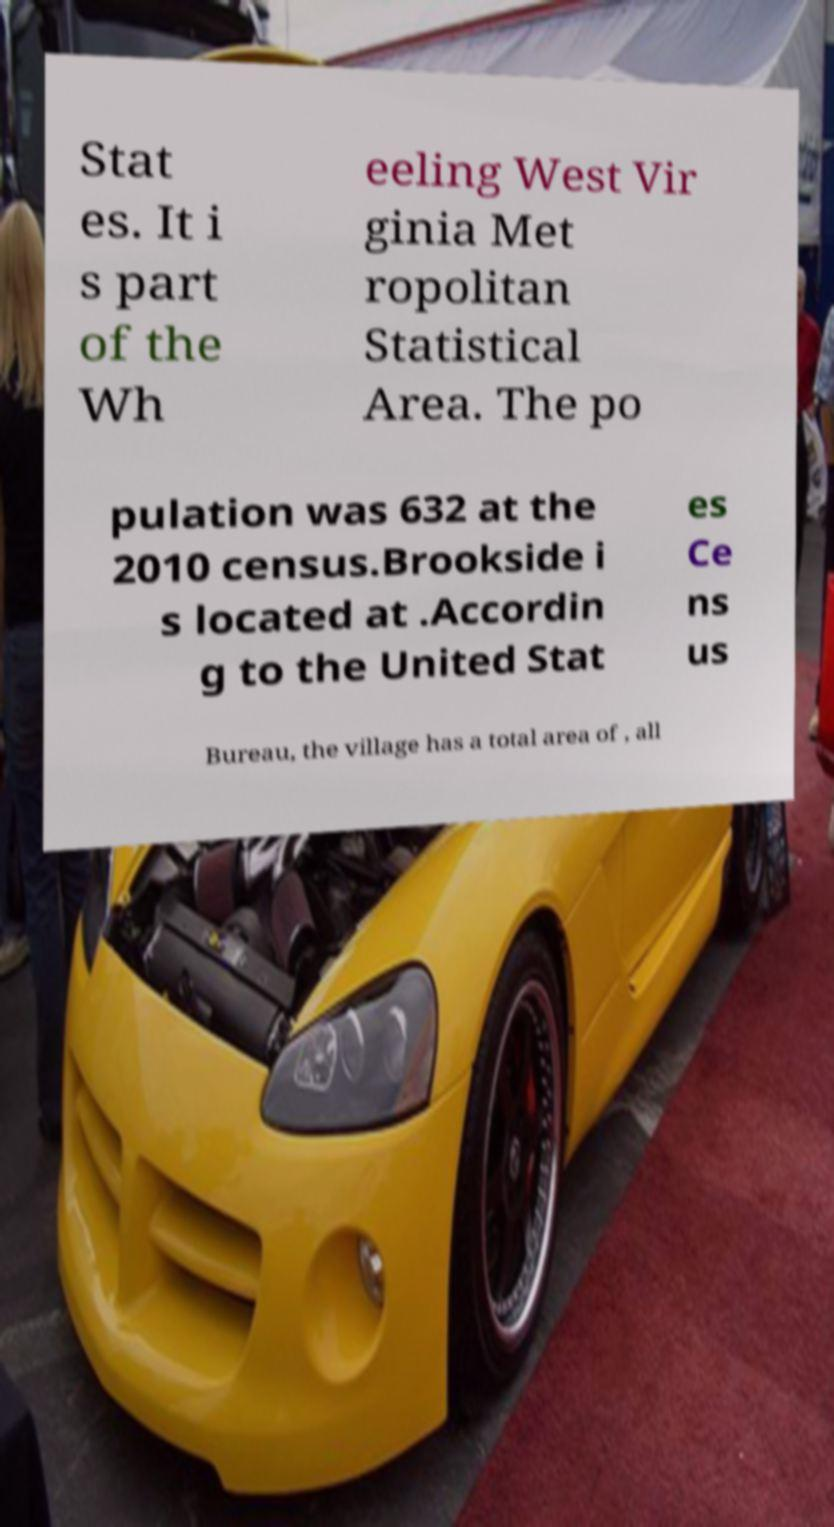Could you assist in decoding the text presented in this image and type it out clearly? Stat es. It i s part of the Wh eeling West Vir ginia Met ropolitan Statistical Area. The po pulation was 632 at the 2010 census.Brookside i s located at .Accordin g to the United Stat es Ce ns us Bureau, the village has a total area of , all 